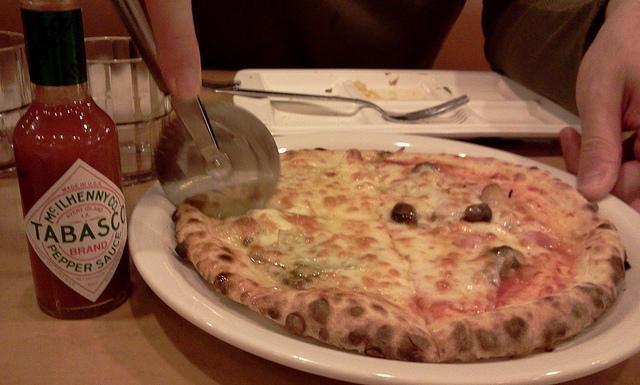Is the given caption "The pizza is right of the bottle." fitting for the image?
Answer yes or no. Yes. 